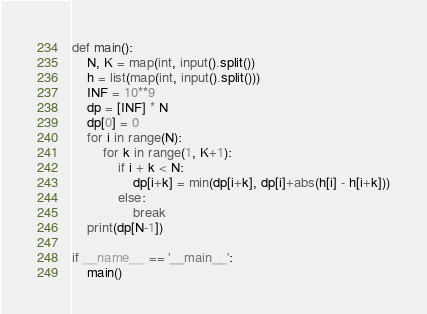Convert code to text. <code><loc_0><loc_0><loc_500><loc_500><_Python_>def main():
    N, K = map(int, input().split())
    h = list(map(int, input().split()))
    INF = 10**9
    dp = [INF] * N
    dp[0] = 0
    for i in range(N):
        for k in range(1, K+1):
            if i + k < N:
                dp[i+k] = min(dp[i+k], dp[i]+abs(h[i] - h[i+k]))
            else:
                break
    print(dp[N-1])

if __name__ == '__main__':
    main()</code> 